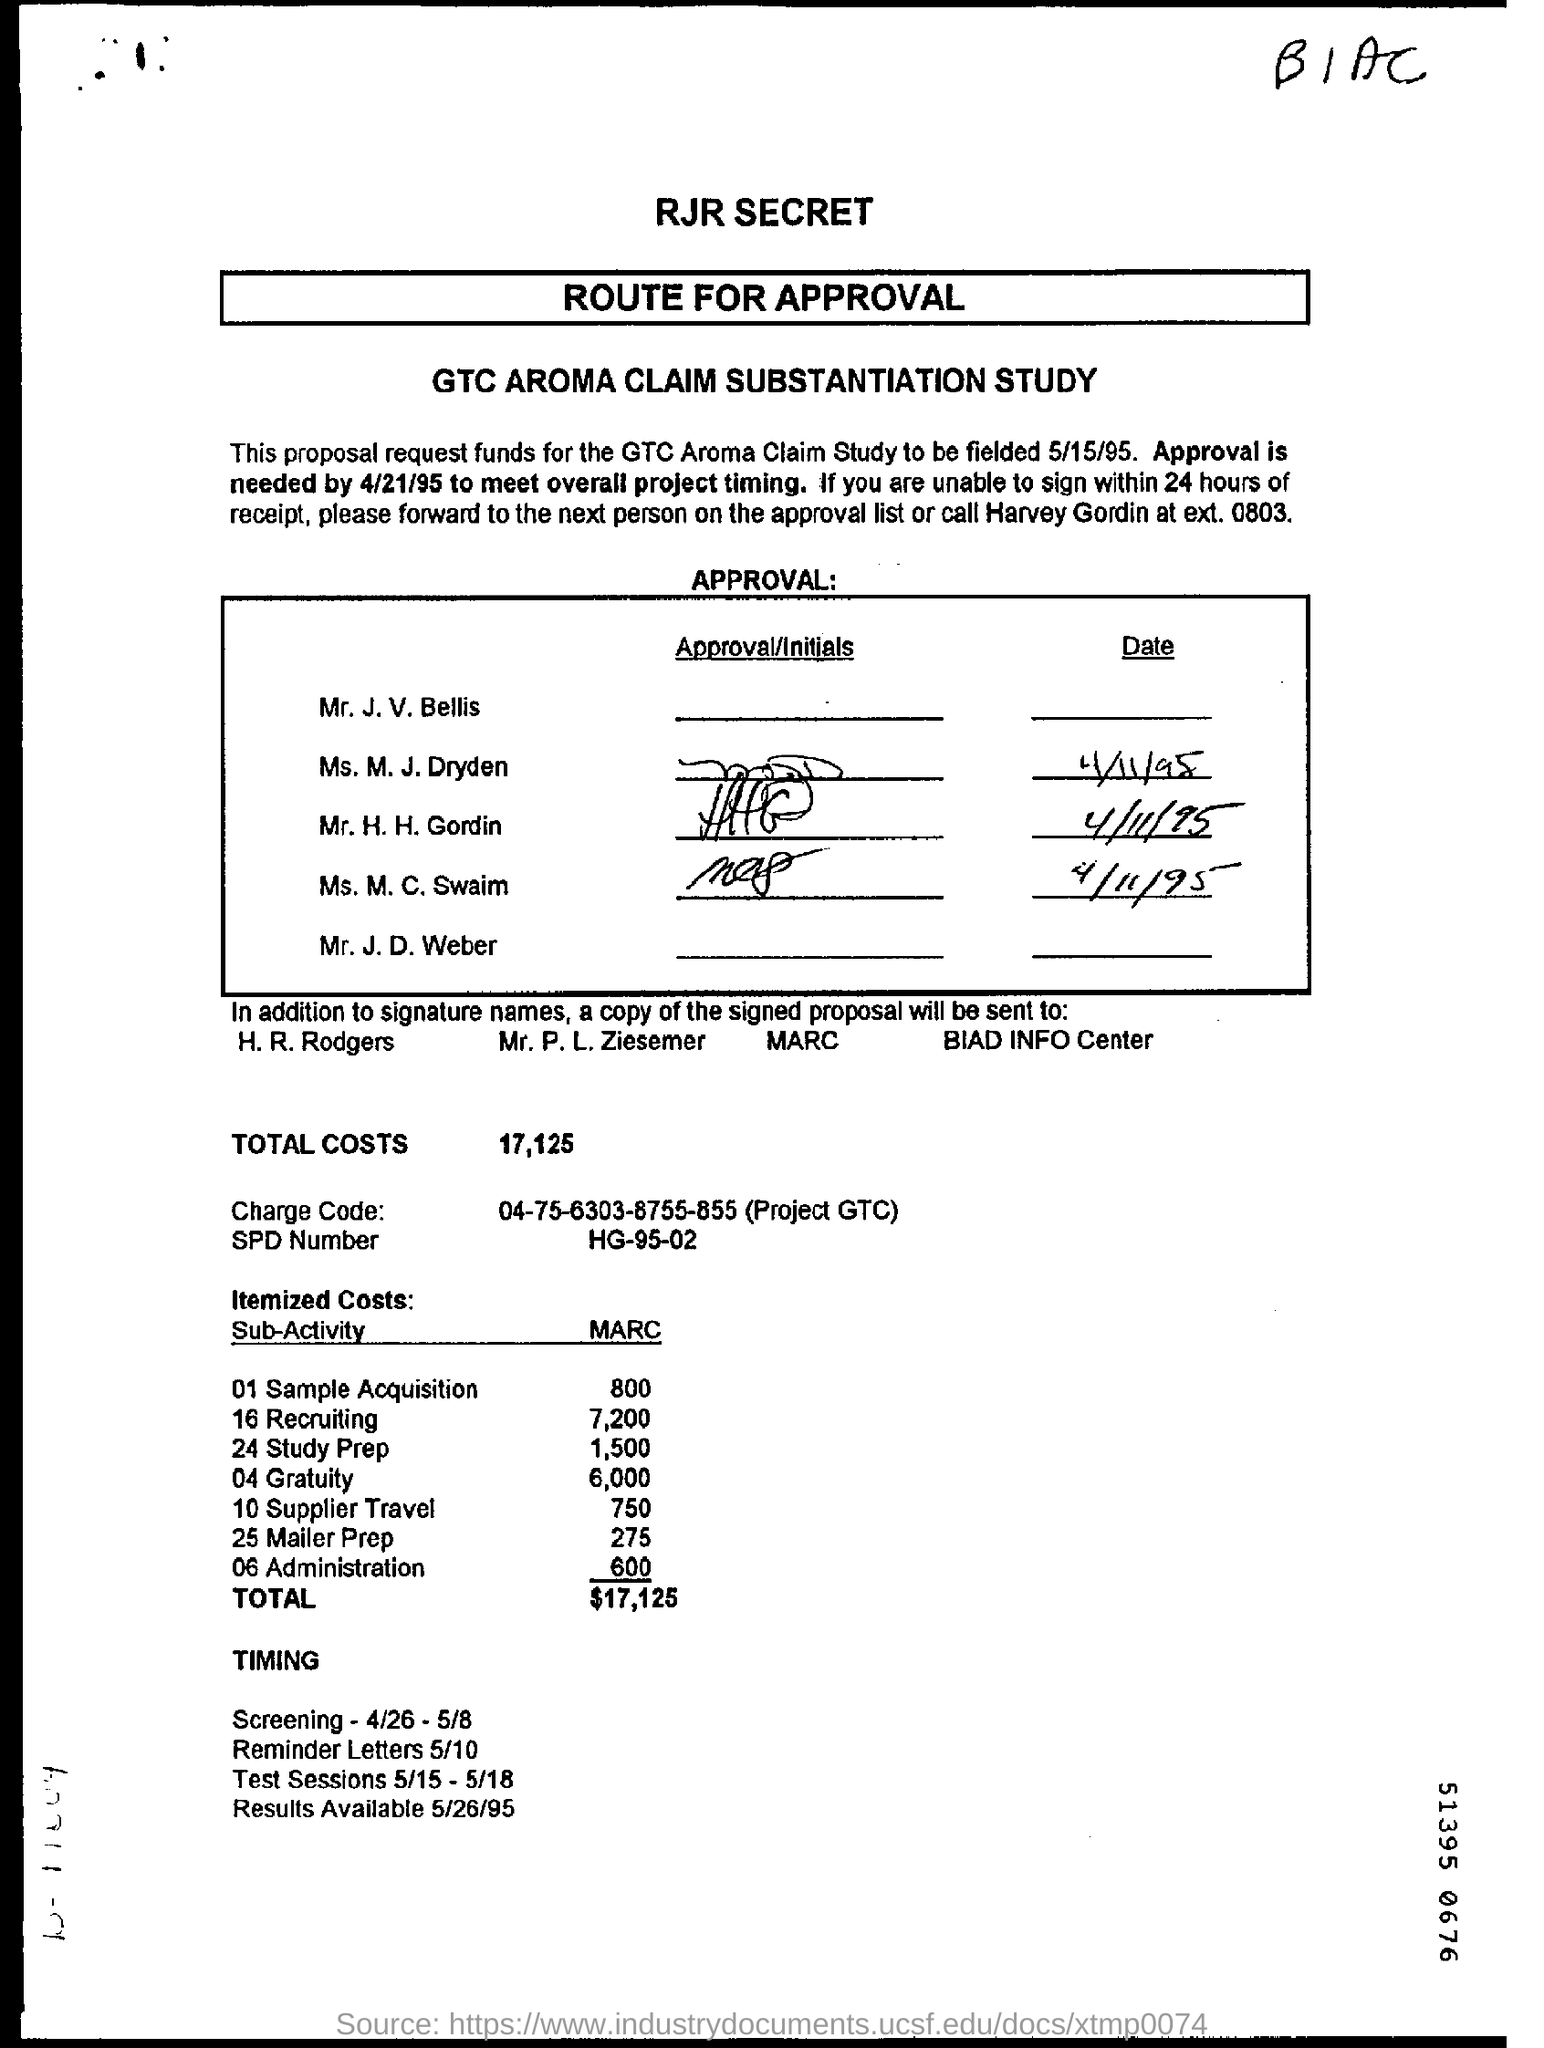Highlight a few significant elements in this photo. The SPD number is HG-95-02. The GTC Aroma Claim Study is scheduled to be fielded on May 15, 1995. The study is called the GTC Aroma Claim Substantiation Study. The approval is needed by April 21, 1995, in order to meet the overall project timeline. 